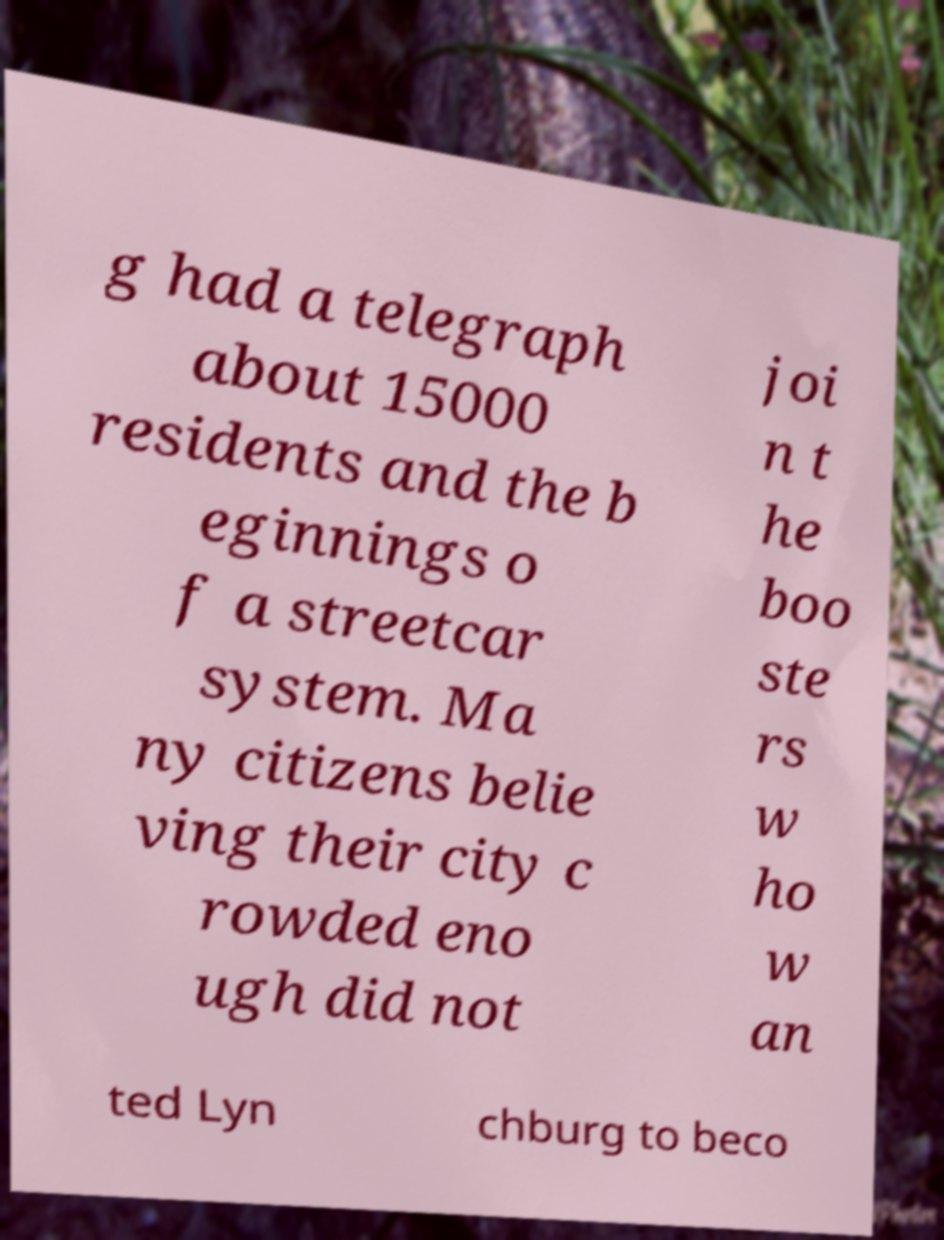Can you accurately transcribe the text from the provided image for me? g had a telegraph about 15000 residents and the b eginnings o f a streetcar system. Ma ny citizens belie ving their city c rowded eno ugh did not joi n t he boo ste rs w ho w an ted Lyn chburg to beco 